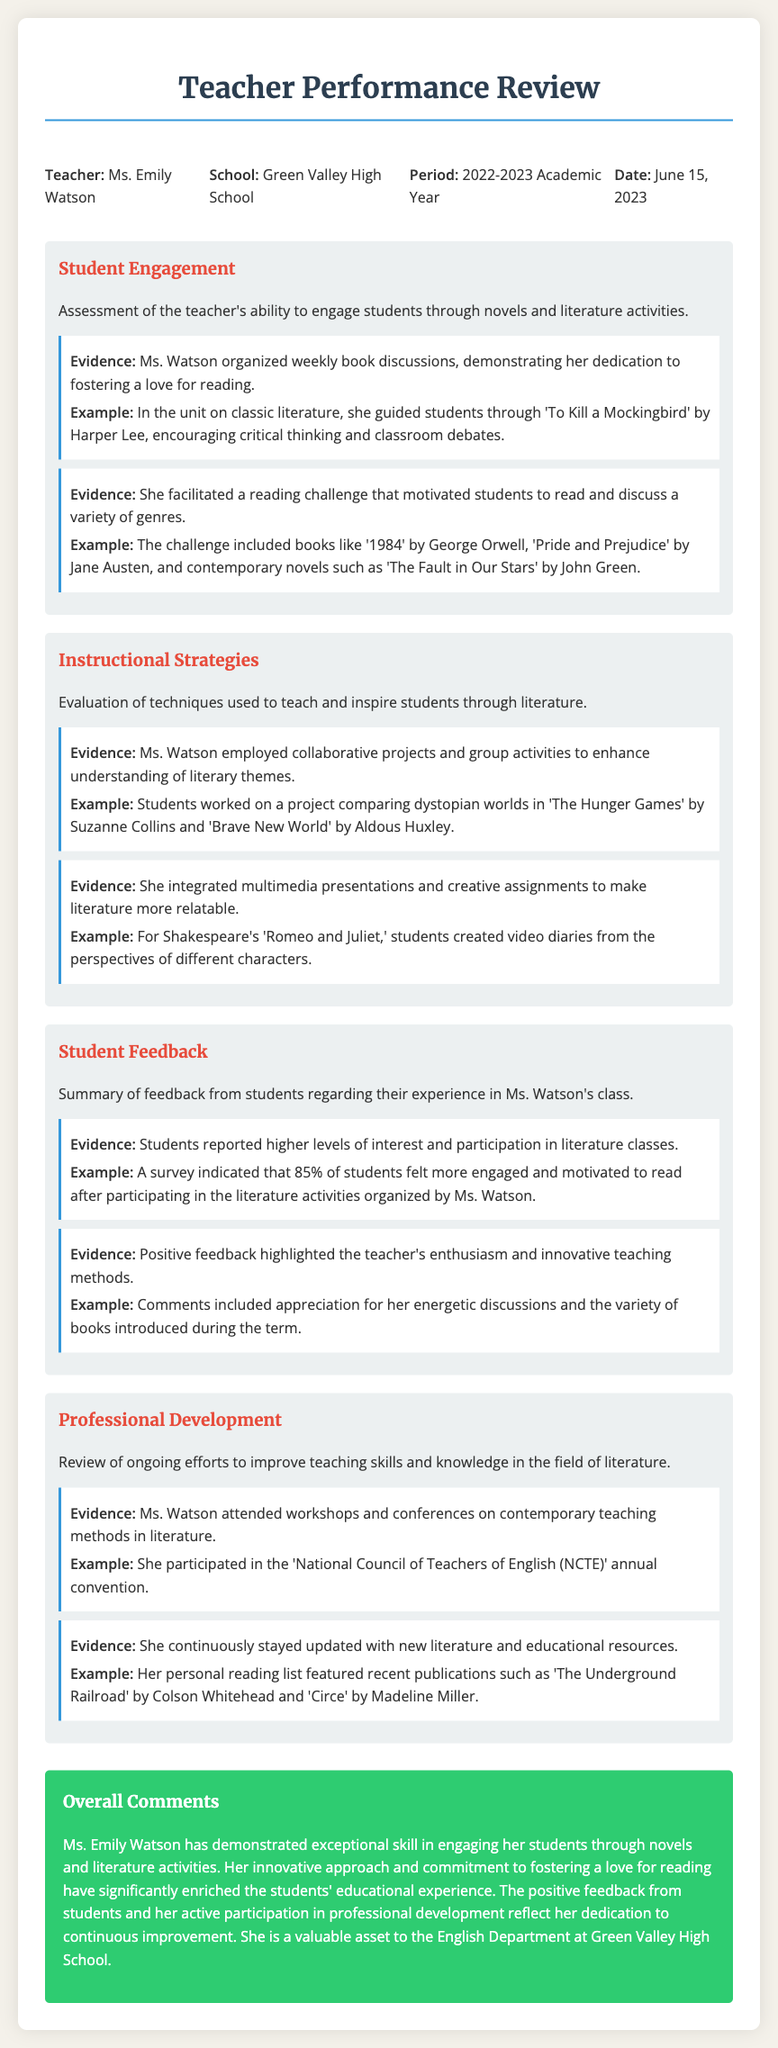What is the name of the teacher being reviewed? The document clearly states the teacher's name at the beginning as Ms. Emily Watson.
Answer: Ms. Emily Watson What school does Ms. Watson teach at? The school name is mentioned in the header information of the document as Green Valley High School.
Answer: Green Valley High School During which academic year was this performance review conducted? The performance review period is specified in the header as the 2022-2023 Academic Year.
Answer: 2022-2023 What percentage of students felt more engaged after participating in the literature activities? The document provides survey results showing that 85% of students reported feeling more engaged.
Answer: 85% Which classic novel did Ms. Watson guide her students through? The document highlights that Ms. Watson guided students through 'To Kill a Mockingbird' by Harper Lee.
Answer: To Kill a Mockingbird What type of projects did Ms. Watson employ to enhance understanding of literary themes? The review mentions that Ms. Watson employed collaborative projects and group activities.
Answer: Collaborative projects and group activities What event did Ms. Watson attend for professional development? The document notes her participation in the 'National Council of Teachers of English (NCTE)' annual convention for professional development.
Answer: National Council of Teachers of English (NCTE) annual convention Which novel is mentioned in the context of students creating video diaries? The document states that for Shakespeare's 'Romeo and Juliet,' students created video diaries.
Answer: Romeo and Juliet What was the overall assessment of Ms. Watson's teaching performance? The overall comments indicate that Ms. Watson demonstrated exceptional skill in engaging her students.
Answer: Exceptional skill 